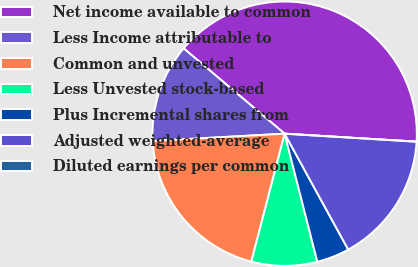<chart> <loc_0><loc_0><loc_500><loc_500><pie_chart><fcel>Net income available to common<fcel>Less Income attributable to<fcel>Common and unvested<fcel>Less Unvested stock-based<fcel>Plus Incremental shares from<fcel>Adjusted weighted-average<fcel>Diluted earnings per common<nl><fcel>39.8%<fcel>12.04%<fcel>20.07%<fcel>8.03%<fcel>4.01%<fcel>16.05%<fcel>0.0%<nl></chart> 